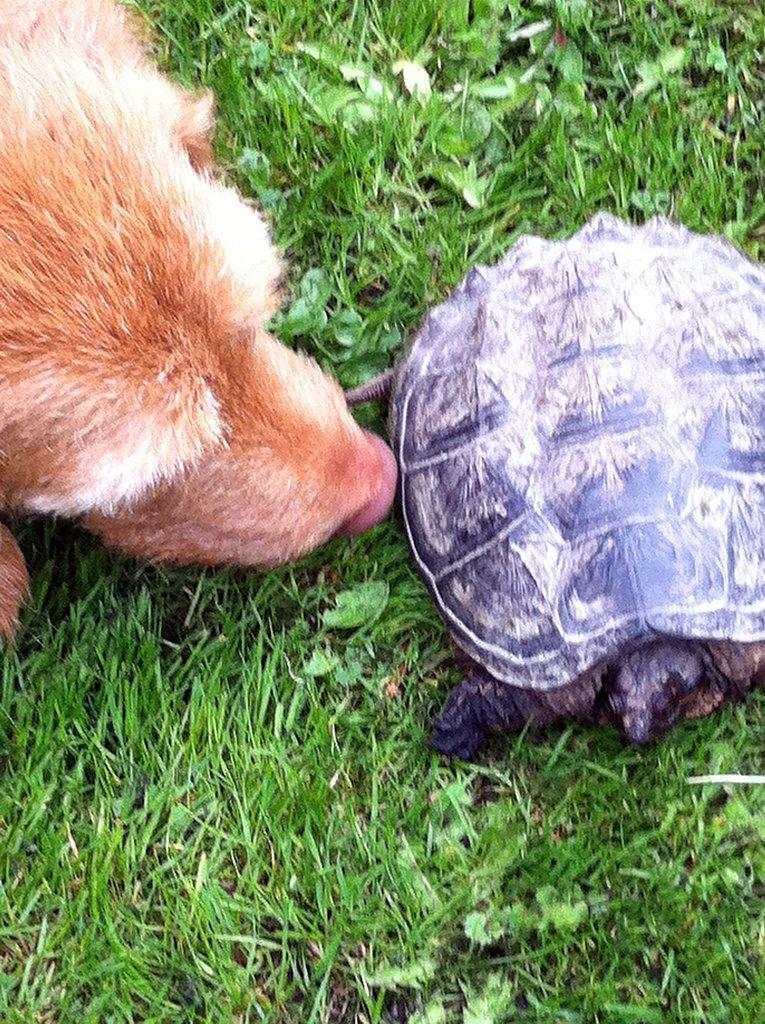In one or two sentences, can you explain what this image depicts? In this image there is a tortoise and an animal on the grassland having plants. 